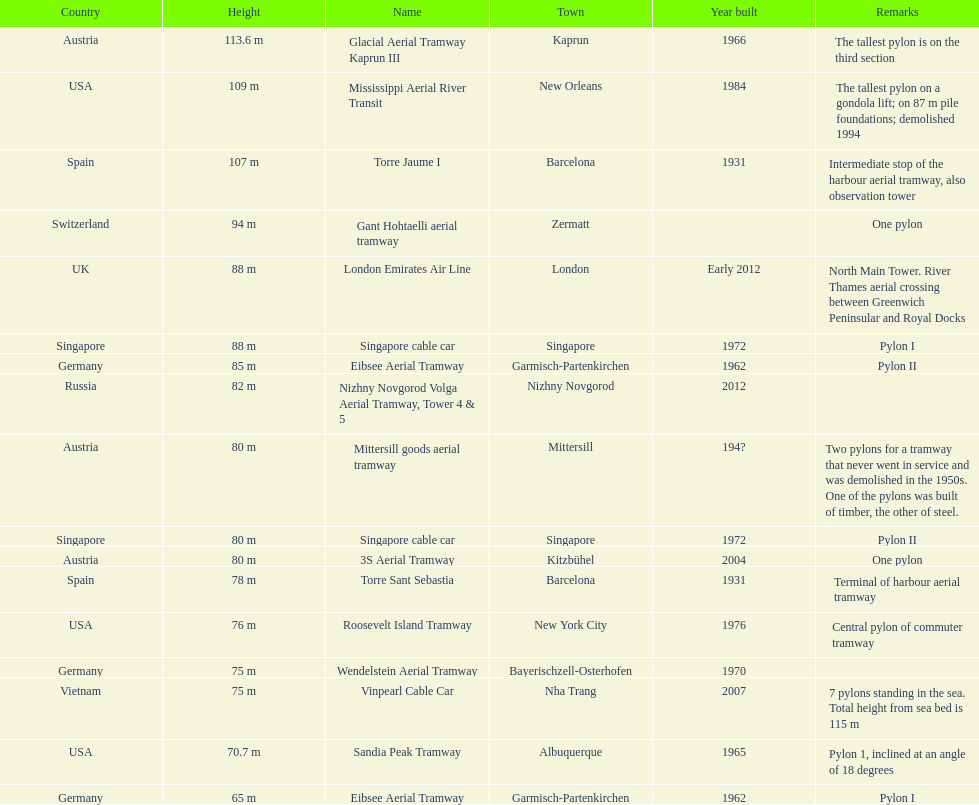The london emirates air line pylon has the same height as which pylon? Singapore cable car. 